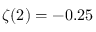<formula> <loc_0><loc_0><loc_500><loc_500>\zeta ( 2 ) = - 0 . 2 5</formula> 